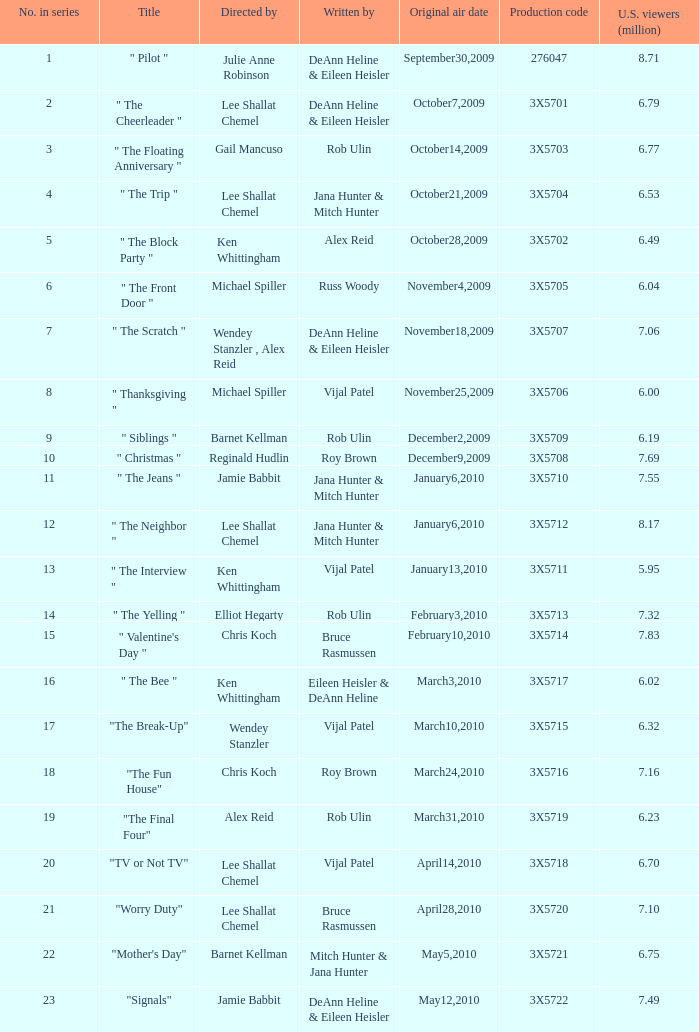What is the designation of the episode under alex reid's direction? "The Final Four". 